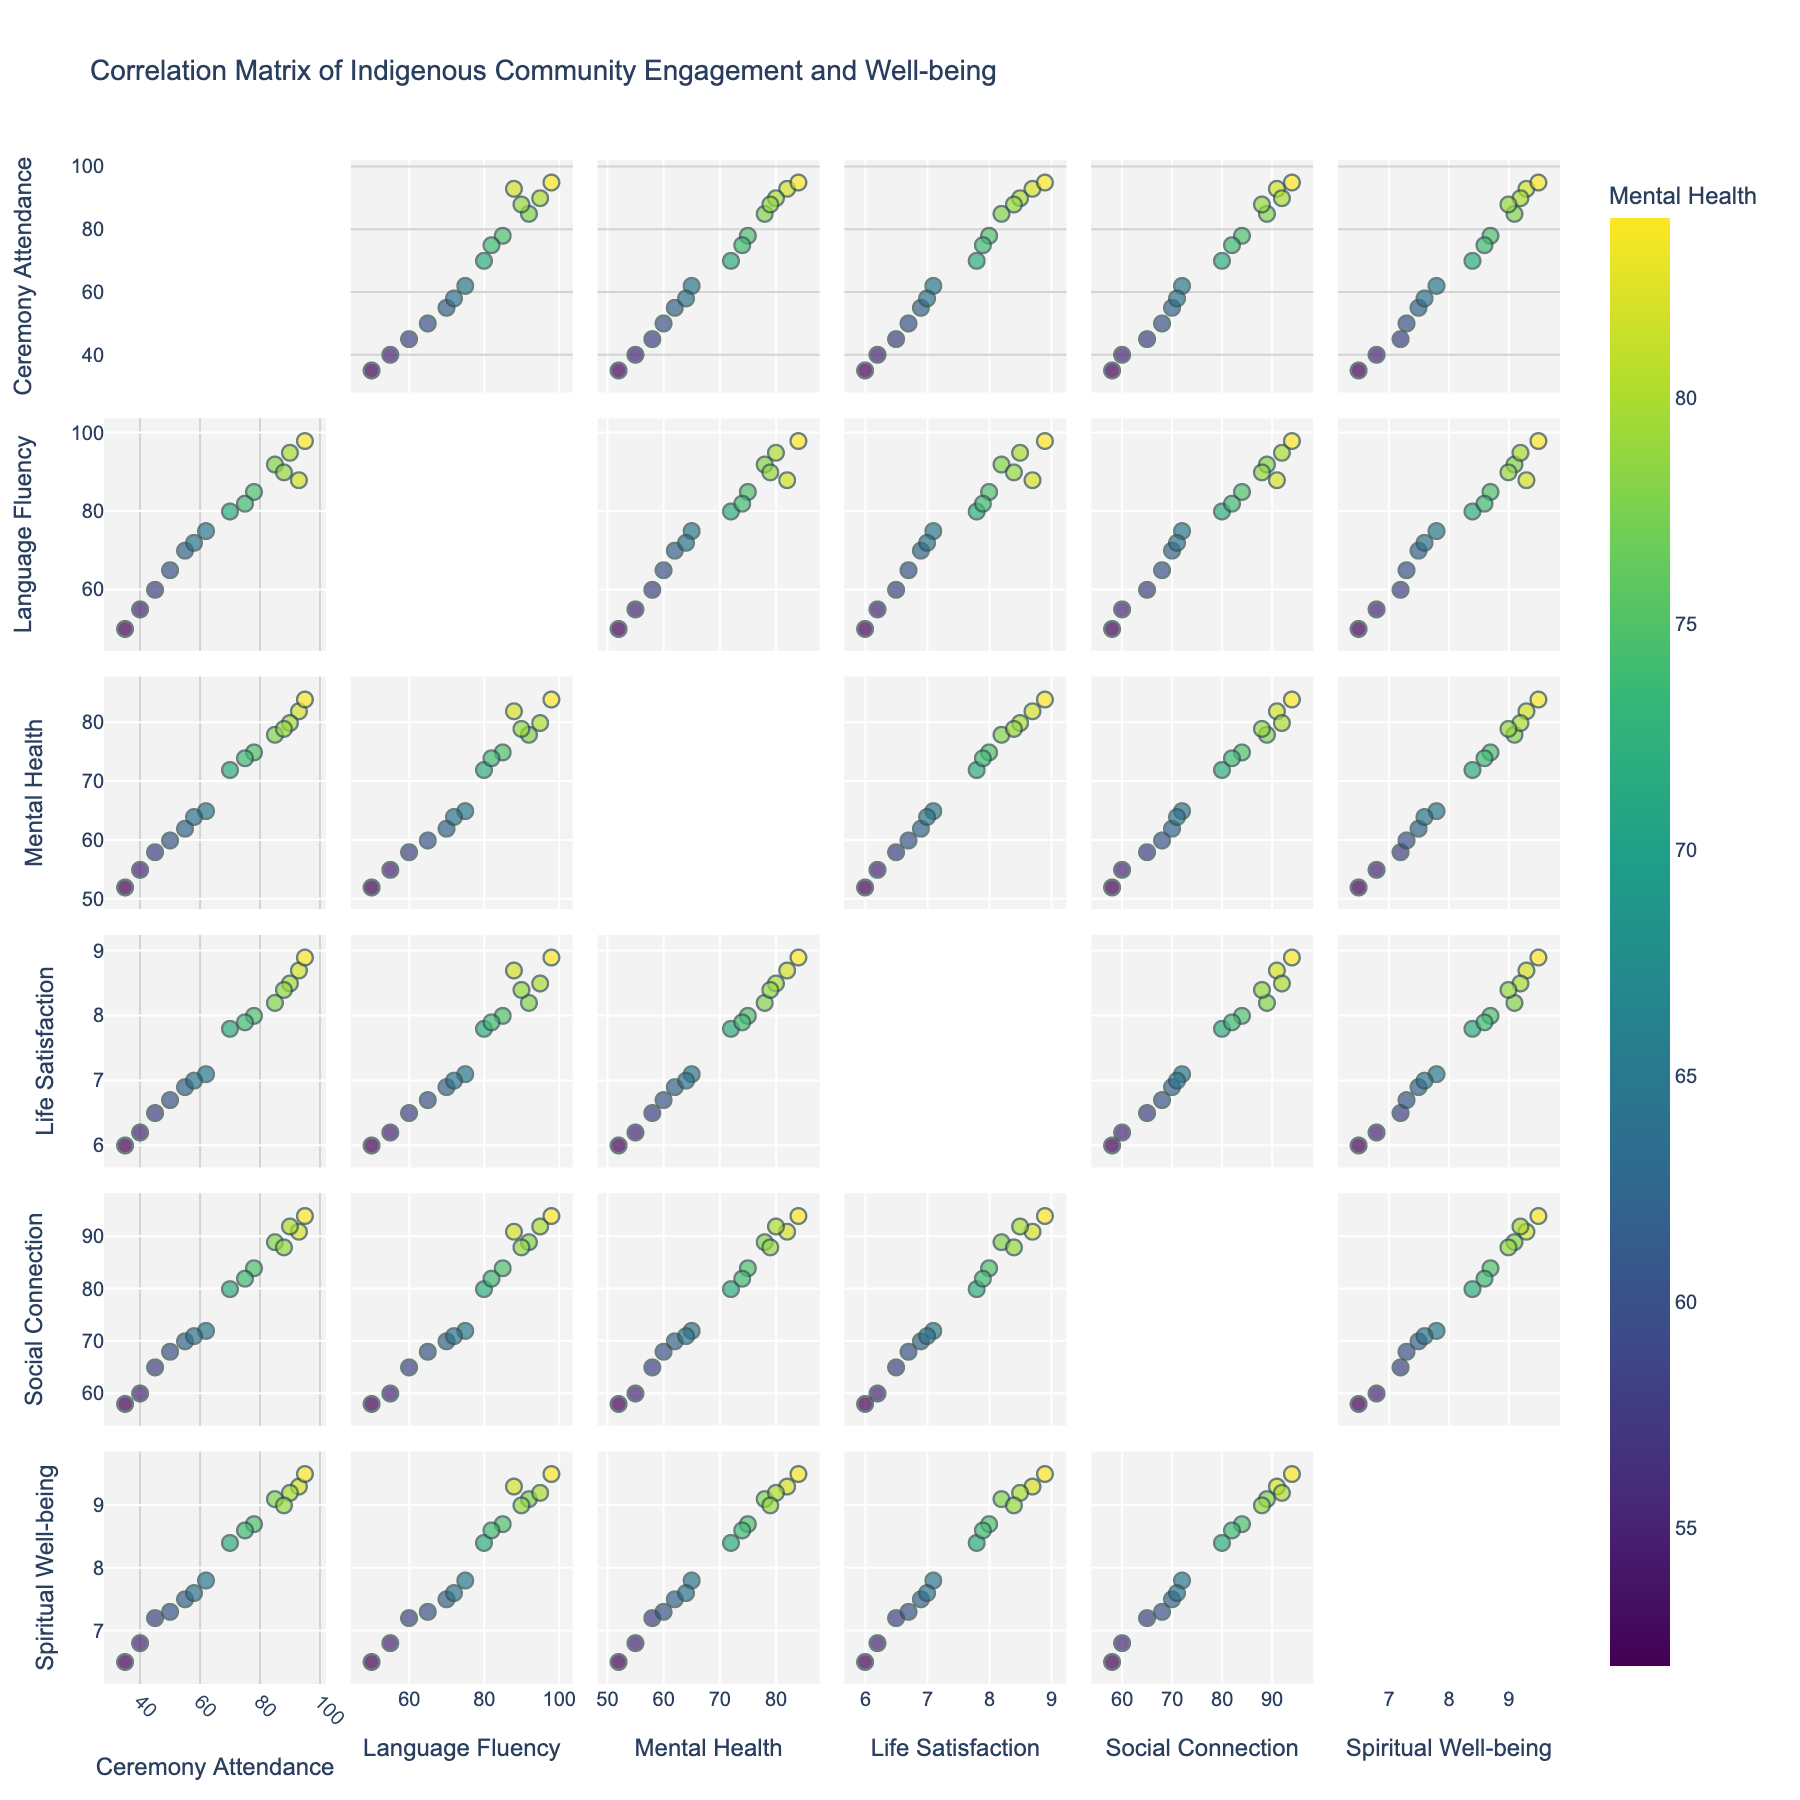What's the title of the figure? The title is written at the top of the scatterplot matrix and provides an overview of the data being visualized.
Answer: Correlation Matrix of Indigenous Community Engagement and Well-being Which variable is used to color the data points? The color legend on the right side of the plot indicates that the data points are colored by the "Mental Health Score" variable.
Answer: Mental Health Score How many dimensions are included in the scatterplot matrix? The dimensions are listed along the diagonal of the scatterplot matrix. By counting those, we can determine the number of dimensions.
Answer: Six What is the relationship between Ceremony Attendance and Social Connectedness? To assess the relationship, observe the scatter plot where Ceremony Attendance is on the x-axis and Social Connectedness is on the y-axis. Look for patterns or trends like positive or negative slopes.
Answer: Positive correlation What is the highest measure of Spiritual Well-being observed, and what is the corresponding Mental Health Score? Locate the scatter plot with Spiritual Well-being on one of the axes. Identify the highest y-value and check its corresponding x-value, which represents the Mental Health Score.
Answer: Spiritual Well-being: 9.5, Mental Health Score: 84 What is the general trend between Traditional Language Fluency and Life Satisfaction? Check the scatter plot where Traditional Language Fluency is on one axis and Life Satisfaction is on the other. Look for any noticeable trends or clusters of points.
Answer: Positive trend Is there an outlier in the relationship between Traditional Language Fluency and Mental Health Score? A point significantly distant from the cluster of points in the scatter plot with Traditional Language Fluency on one axis and Mental Health Score on the other would indicate an outlier.
Answer: Yes (at 50, 52) Between Social Connectedness and Life Satisfaction, which scatterplot seems to have a tighter correlation? Compare the scatterplots to see the dispersion of points. A tighter cluster indicates a stronger correlation.
Answer: Social Connectedness and Life Satisfaction Is there a noticeable clustering of points in the scatter plot between Mental Health Score and Life Satisfaction? Look at the scatter plot where Mental Health Score is on one axis and Life Satisfaction is on the other for any clusters or groupings of points.
Answer: Yes 